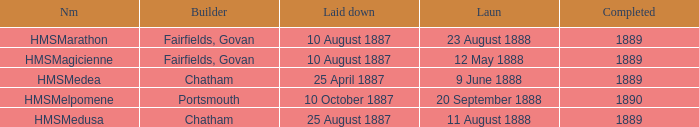What boat was laid down on 25 april 1887? HMSMedea. 